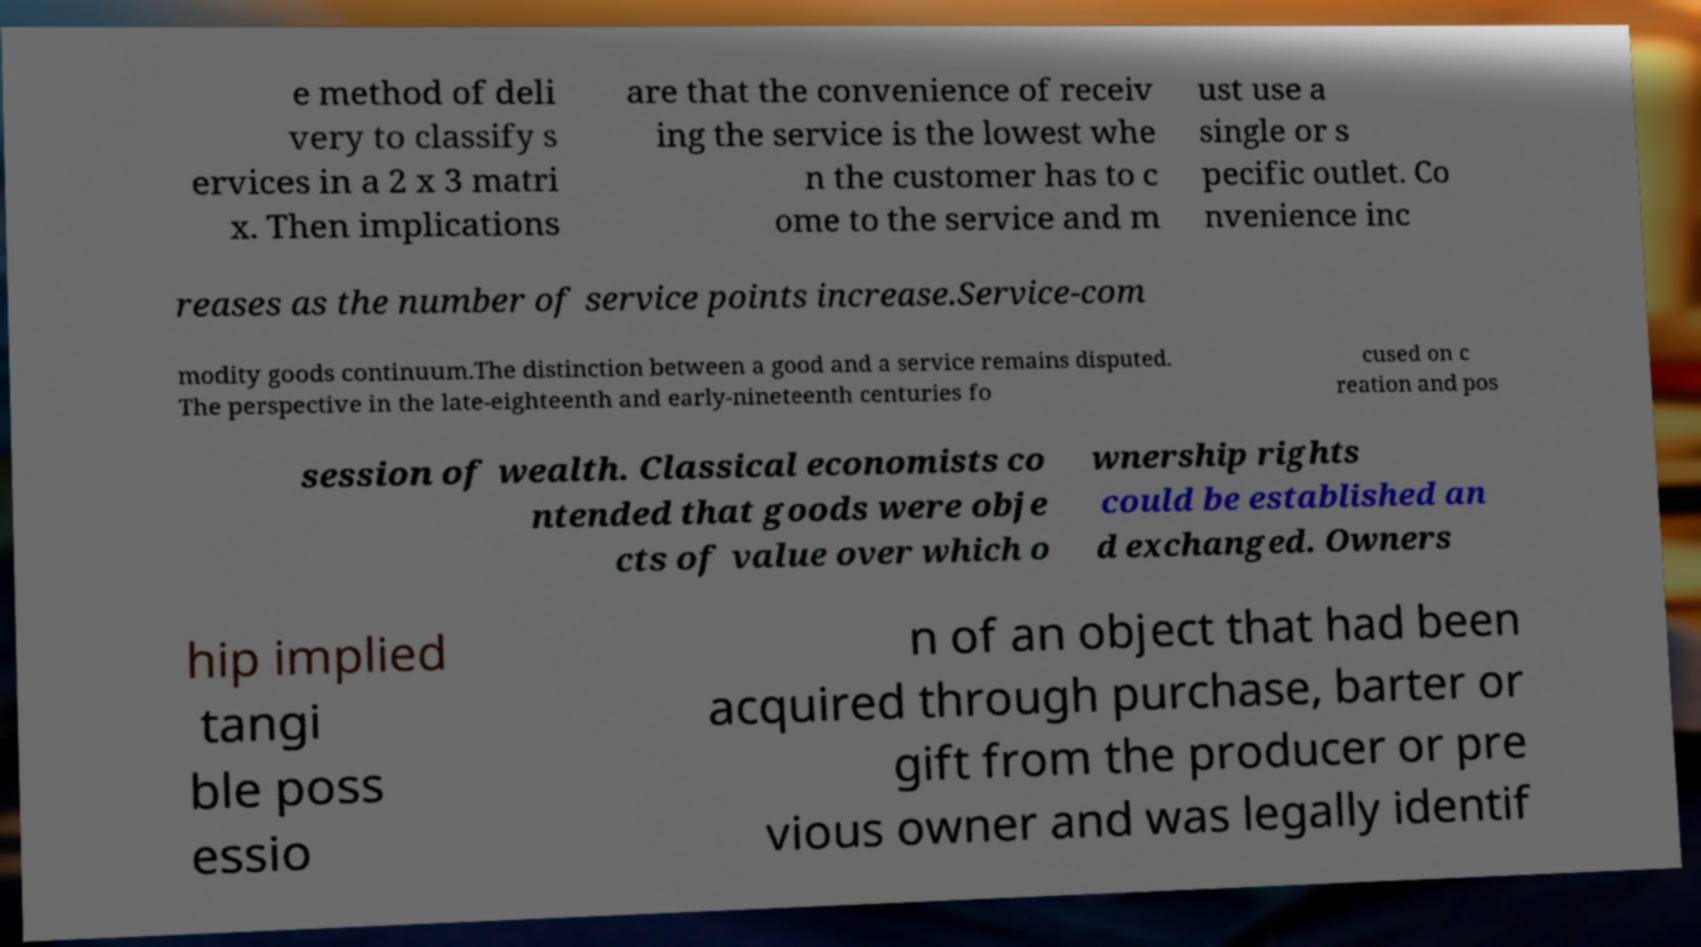There's text embedded in this image that I need extracted. Can you transcribe it verbatim? e method of deli very to classify s ervices in a 2 x 3 matri x. Then implications are that the convenience of receiv ing the service is the lowest whe n the customer has to c ome to the service and m ust use a single or s pecific outlet. Co nvenience inc reases as the number of service points increase.Service-com modity goods continuum.The distinction between a good and a service remains disputed. The perspective in the late-eighteenth and early-nineteenth centuries fo cused on c reation and pos session of wealth. Classical economists co ntended that goods were obje cts of value over which o wnership rights could be established an d exchanged. Owners hip implied tangi ble poss essio n of an object that had been acquired through purchase, barter or gift from the producer or pre vious owner and was legally identif 